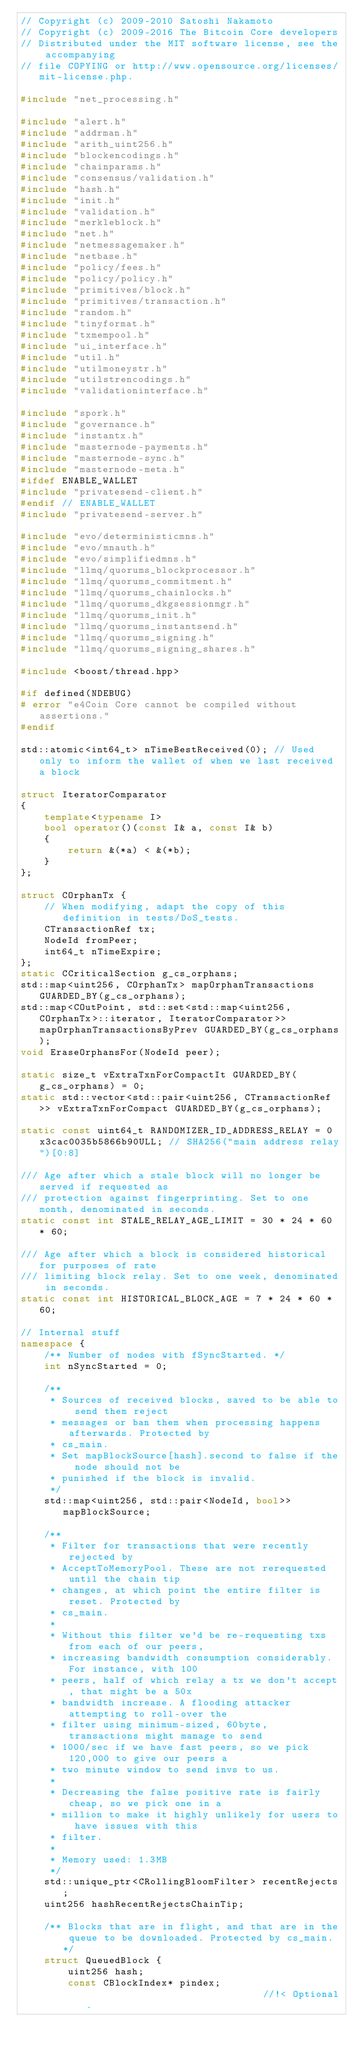<code> <loc_0><loc_0><loc_500><loc_500><_C++_>// Copyright (c) 2009-2010 Satoshi Nakamoto
// Copyright (c) 2009-2016 The Bitcoin Core developers
// Distributed under the MIT software license, see the accompanying
// file COPYING or http://www.opensource.org/licenses/mit-license.php.

#include "net_processing.h"

#include "alert.h"
#include "addrman.h"
#include "arith_uint256.h"
#include "blockencodings.h"
#include "chainparams.h"
#include "consensus/validation.h"
#include "hash.h"
#include "init.h"
#include "validation.h"
#include "merkleblock.h"
#include "net.h"
#include "netmessagemaker.h"
#include "netbase.h"
#include "policy/fees.h"
#include "policy/policy.h"
#include "primitives/block.h"
#include "primitives/transaction.h"
#include "random.h"
#include "tinyformat.h"
#include "txmempool.h"
#include "ui_interface.h"
#include "util.h"
#include "utilmoneystr.h"
#include "utilstrencodings.h"
#include "validationinterface.h"

#include "spork.h"
#include "governance.h"
#include "instantx.h"
#include "masternode-payments.h"
#include "masternode-sync.h"
#include "masternode-meta.h"
#ifdef ENABLE_WALLET
#include "privatesend-client.h"
#endif // ENABLE_WALLET
#include "privatesend-server.h"

#include "evo/deterministicmns.h"
#include "evo/mnauth.h"
#include "evo/simplifiedmns.h"
#include "llmq/quorums_blockprocessor.h"
#include "llmq/quorums_commitment.h"
#include "llmq/quorums_chainlocks.h"
#include "llmq/quorums_dkgsessionmgr.h"
#include "llmq/quorums_init.h"
#include "llmq/quorums_instantsend.h"
#include "llmq/quorums_signing.h"
#include "llmq/quorums_signing_shares.h"

#include <boost/thread.hpp>

#if defined(NDEBUG)
# error "e4Coin Core cannot be compiled without assertions."
#endif

std::atomic<int64_t> nTimeBestReceived(0); // Used only to inform the wallet of when we last received a block

struct IteratorComparator
{
    template<typename I>
    bool operator()(const I& a, const I& b)
    {
        return &(*a) < &(*b);
    }
};

struct COrphanTx {
    // When modifying, adapt the copy of this definition in tests/DoS_tests.
    CTransactionRef tx;
    NodeId fromPeer;
    int64_t nTimeExpire;
};
static CCriticalSection g_cs_orphans;
std::map<uint256, COrphanTx> mapOrphanTransactions GUARDED_BY(g_cs_orphans);
std::map<COutPoint, std::set<std::map<uint256, COrphanTx>::iterator, IteratorComparator>> mapOrphanTransactionsByPrev GUARDED_BY(g_cs_orphans);
void EraseOrphansFor(NodeId peer);

static size_t vExtraTxnForCompactIt GUARDED_BY(g_cs_orphans) = 0;
static std::vector<std::pair<uint256, CTransactionRef>> vExtraTxnForCompact GUARDED_BY(g_cs_orphans);

static const uint64_t RANDOMIZER_ID_ADDRESS_RELAY = 0x3cac0035b5866b90ULL; // SHA256("main address relay")[0:8]

/// Age after which a stale block will no longer be served if requested as
/// protection against fingerprinting. Set to one month, denominated in seconds.
static const int STALE_RELAY_AGE_LIMIT = 30 * 24 * 60 * 60;

/// Age after which a block is considered historical for purposes of rate
/// limiting block relay. Set to one week, denominated in seconds.
static const int HISTORICAL_BLOCK_AGE = 7 * 24 * 60 * 60;

// Internal stuff
namespace {
    /** Number of nodes with fSyncStarted. */
    int nSyncStarted = 0;

    /**
     * Sources of received blocks, saved to be able to send them reject
     * messages or ban them when processing happens afterwards. Protected by
     * cs_main.
     * Set mapBlockSource[hash].second to false if the node should not be
     * punished if the block is invalid.
     */
    std::map<uint256, std::pair<NodeId, bool>> mapBlockSource;

    /**
     * Filter for transactions that were recently rejected by
     * AcceptToMemoryPool. These are not rerequested until the chain tip
     * changes, at which point the entire filter is reset. Protected by
     * cs_main.
     *
     * Without this filter we'd be re-requesting txs from each of our peers,
     * increasing bandwidth consumption considerably. For instance, with 100
     * peers, half of which relay a tx we don't accept, that might be a 50x
     * bandwidth increase. A flooding attacker attempting to roll-over the
     * filter using minimum-sized, 60byte, transactions might manage to send
     * 1000/sec if we have fast peers, so we pick 120,000 to give our peers a
     * two minute window to send invs to us.
     *
     * Decreasing the false positive rate is fairly cheap, so we pick one in a
     * million to make it highly unlikely for users to have issues with this
     * filter.
     *
     * Memory used: 1.3MB
     */
    std::unique_ptr<CRollingBloomFilter> recentRejects;
    uint256 hashRecentRejectsChainTip;

    /** Blocks that are in flight, and that are in the queue to be downloaded. Protected by cs_main. */
    struct QueuedBlock {
        uint256 hash;
        const CBlockIndex* pindex;                               //!< Optional.</code> 